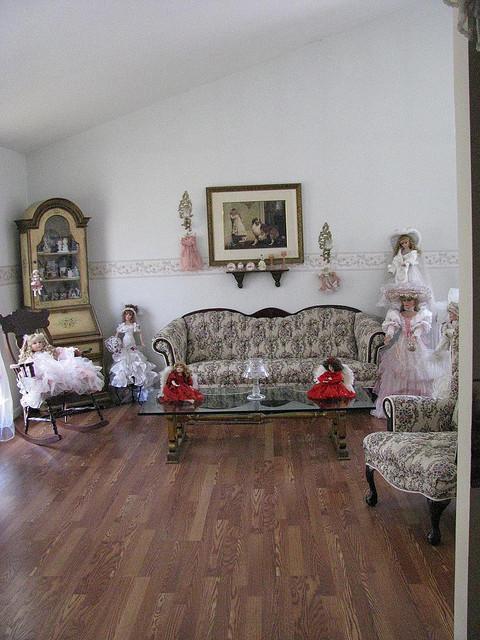How many chairs are visible?
Give a very brief answer. 2. How many cups on the table are wine glasses?
Give a very brief answer. 0. 